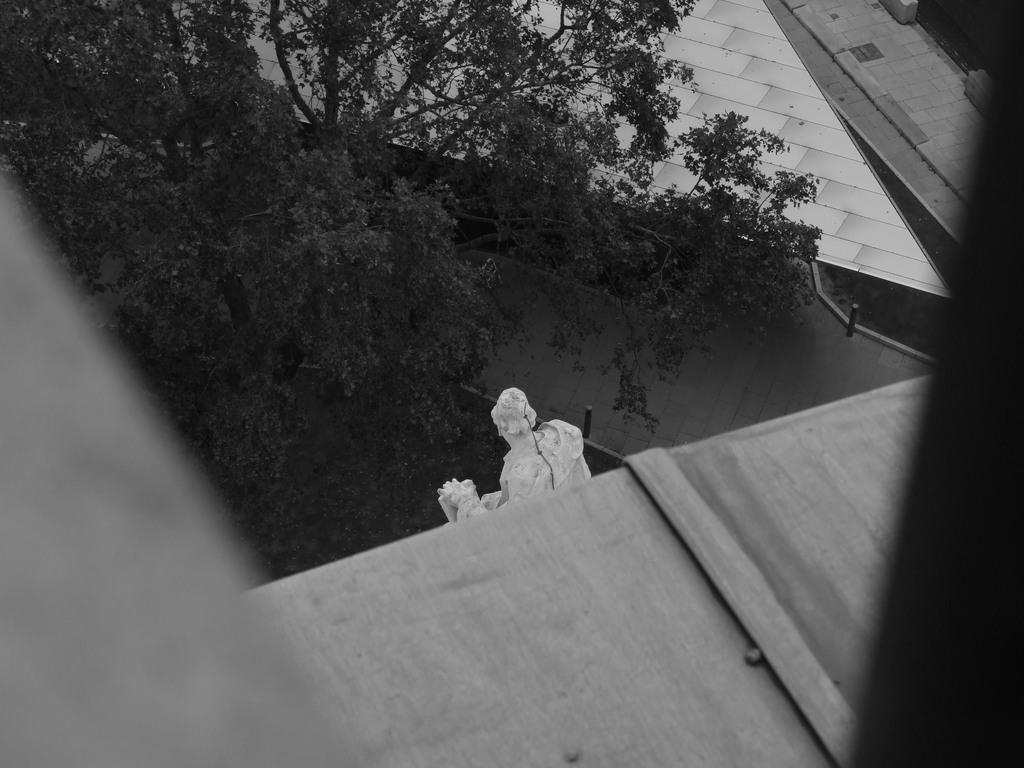What is the color scheme of the image? The image is black and white. What is the main subject in the image? There is a statue in the image. What other objects or features can be seen in the image? There is a tree and the roof of a building visible in the image. How many apples are hanging from the tree in the image? There are no apples present in the image; it only features a tree and a statue. What type of test is being conducted in the image? There is no test being conducted in the image; it is a black and white photograph of a statue, a tree, and a building. 